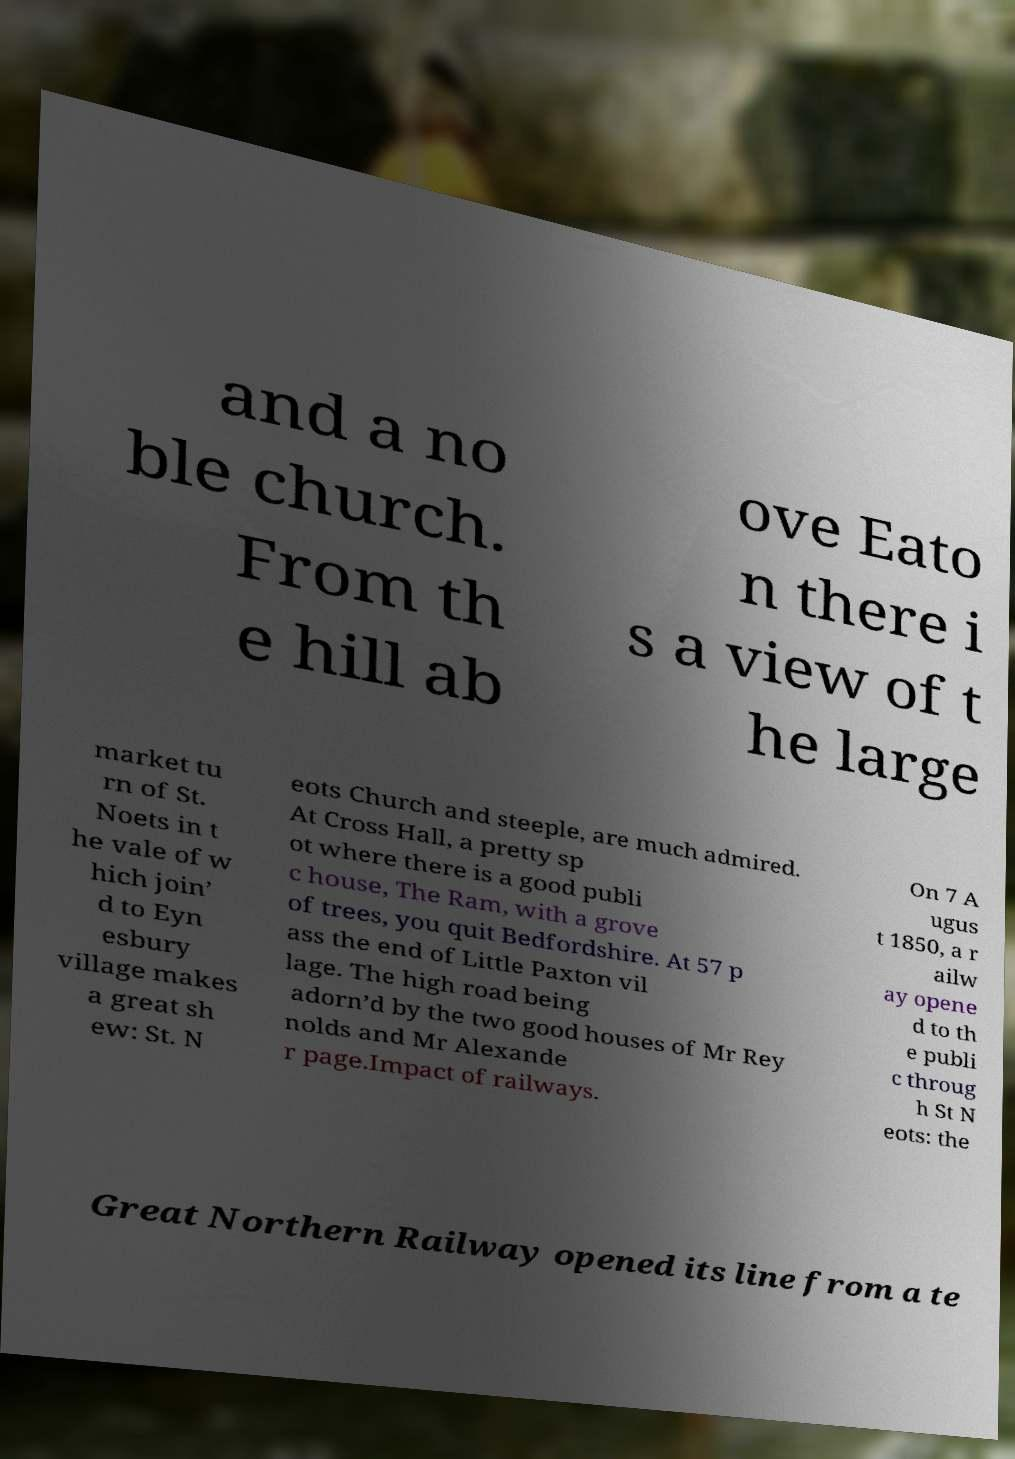I need the written content from this picture converted into text. Can you do that? and a no ble church. From th e hill ab ove Eato n there i s a view of t he large market tu rn of St. Noets in t he vale of w hich join’ d to Eyn esbury village makes a great sh ew: St. N eots Church and steeple, are much admired. At Cross Hall, a pretty sp ot where there is a good publi c house, The Ram, with a grove of trees, you quit Bedfordshire. At 57 p ass the end of Little Paxton vil lage. The high road being adorn’d by the two good houses of Mr Rey nolds and Mr Alexande r page.Impact of railways. On 7 A ugus t 1850, a r ailw ay opene d to th e publi c throug h St N eots: the Great Northern Railway opened its line from a te 